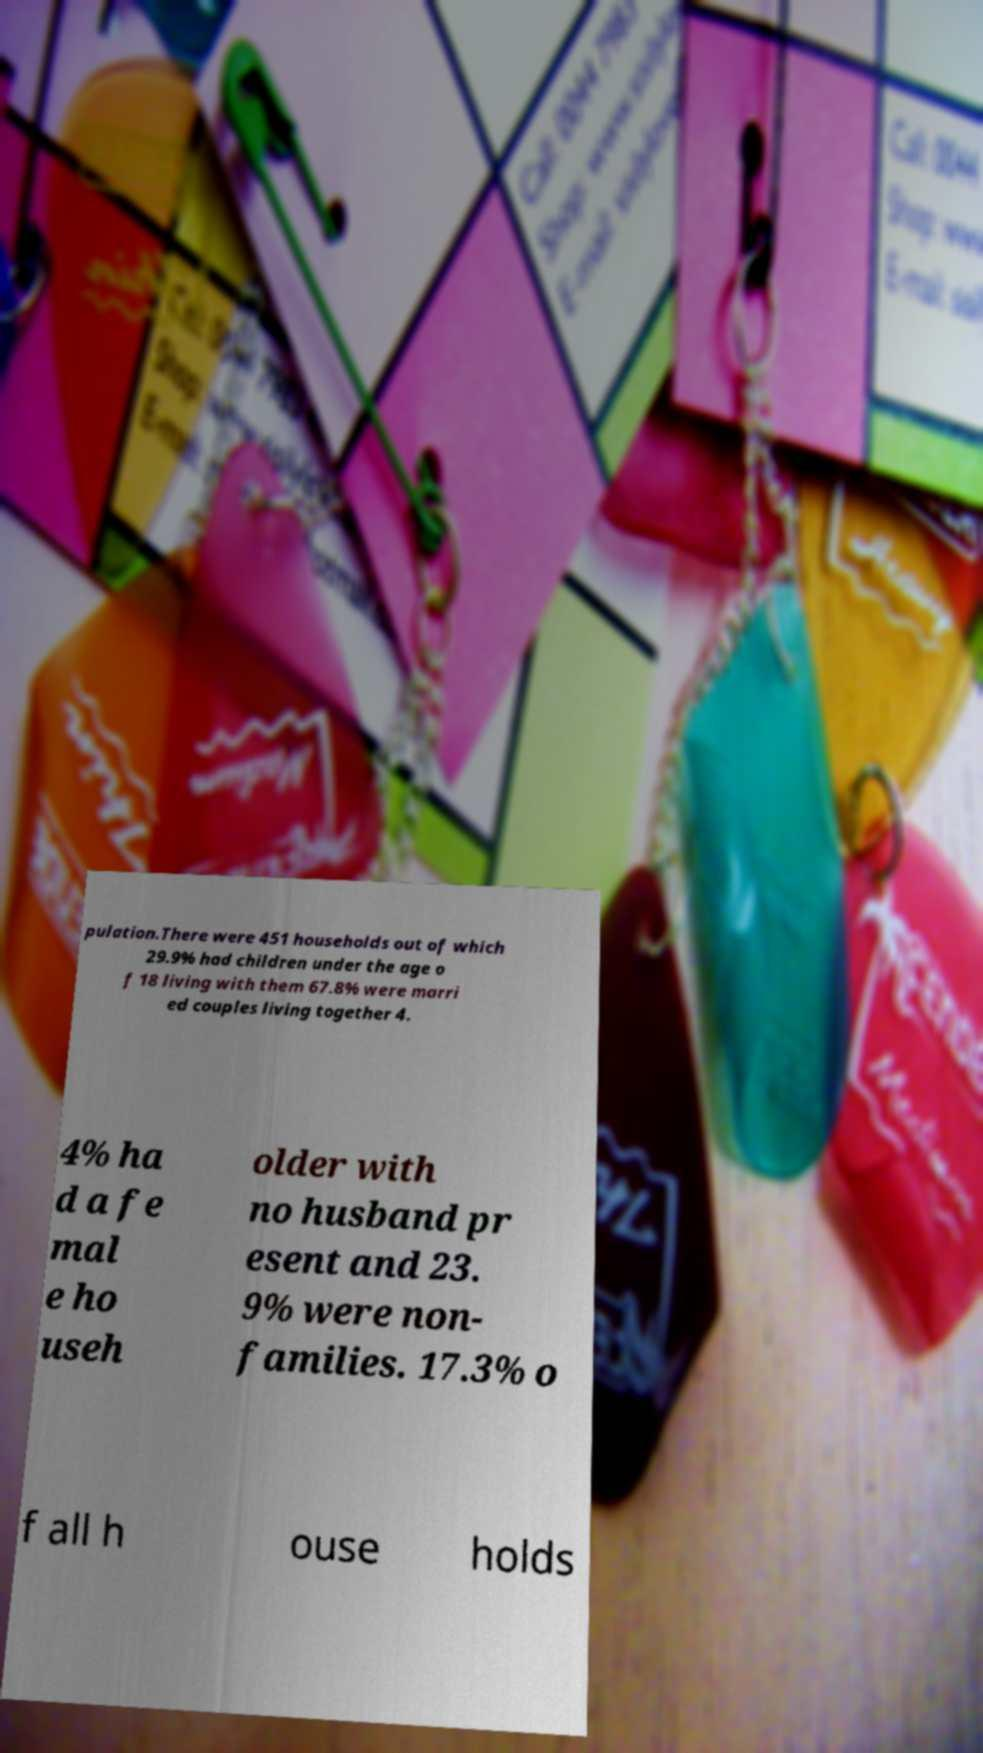Could you assist in decoding the text presented in this image and type it out clearly? pulation.There were 451 households out of which 29.9% had children under the age o f 18 living with them 67.8% were marri ed couples living together 4. 4% ha d a fe mal e ho useh older with no husband pr esent and 23. 9% were non- families. 17.3% o f all h ouse holds 